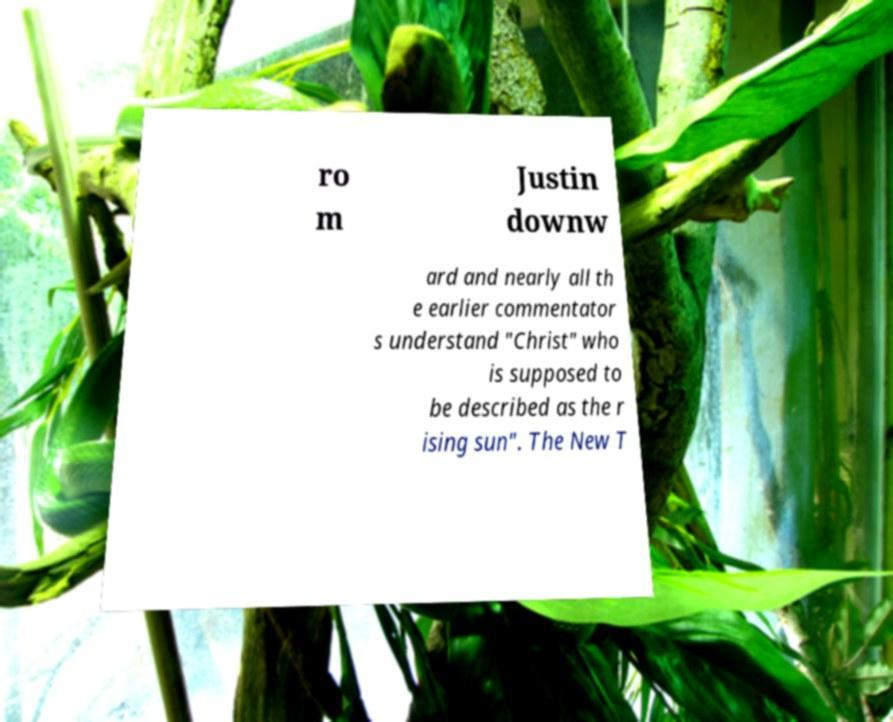Please identify and transcribe the text found in this image. ro m Justin downw ard and nearly all th e earlier commentator s understand "Christ" who is supposed to be described as the r ising sun". The New T 